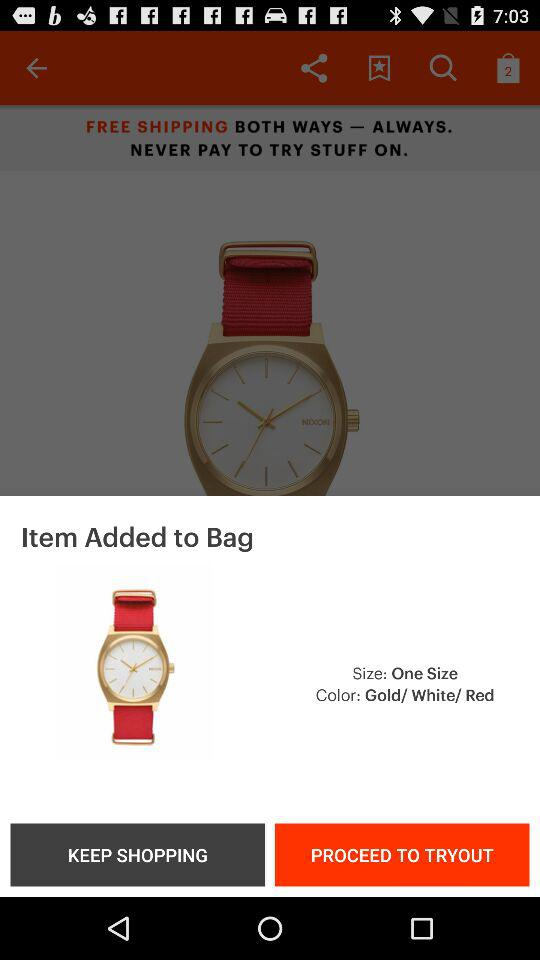What is the mentioned size? The mentioned size is "One Size". 